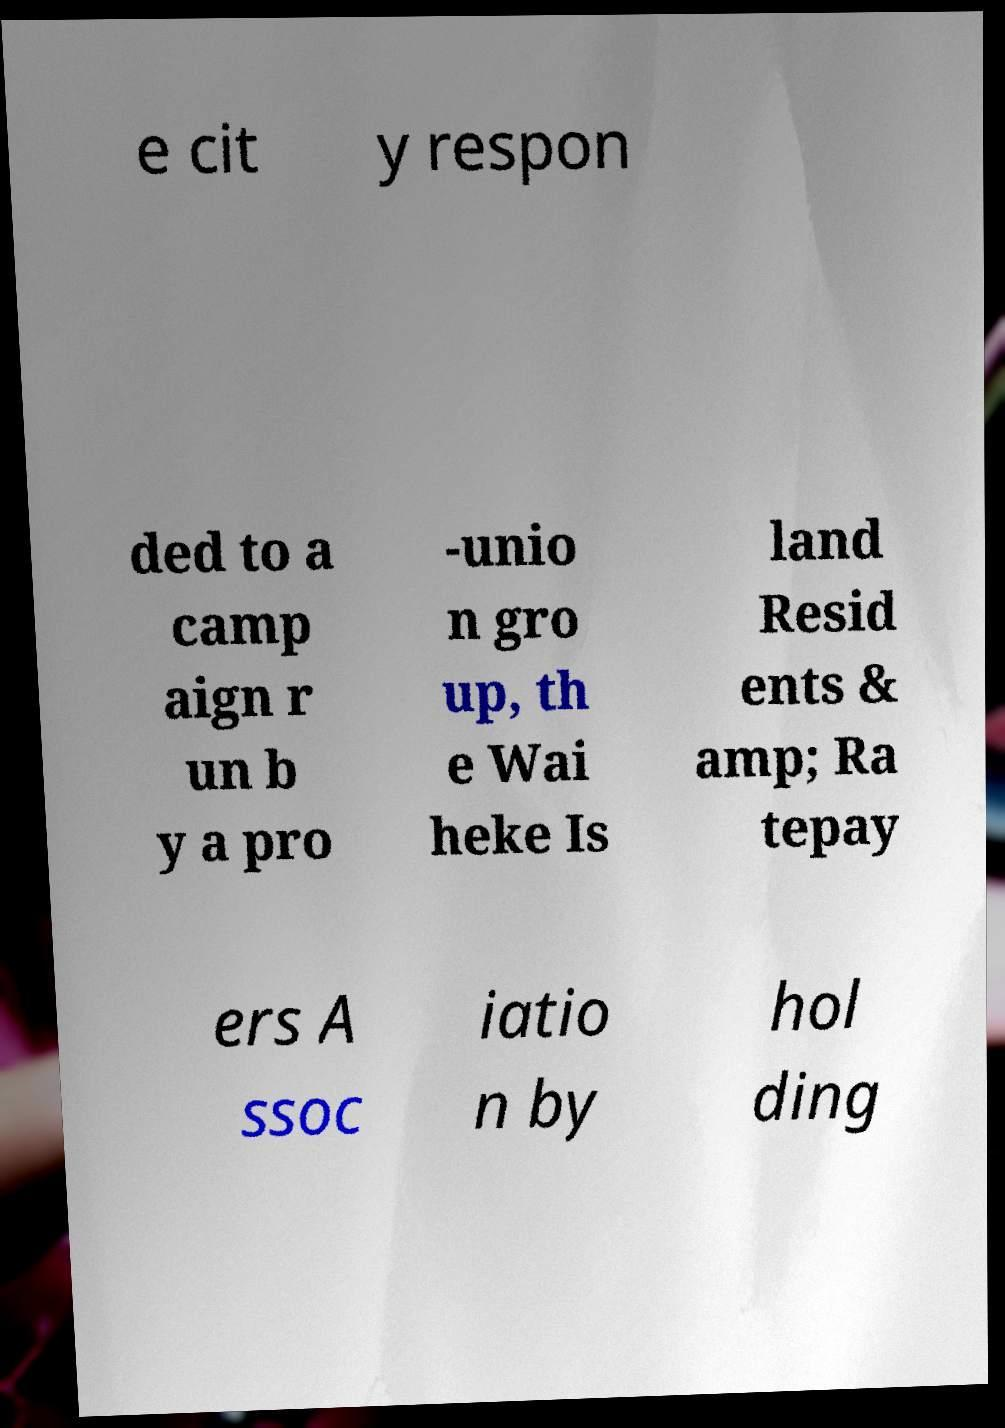Could you assist in decoding the text presented in this image and type it out clearly? e cit y respon ded to a camp aign r un b y a pro -unio n gro up, th e Wai heke Is land Resid ents & amp; Ra tepay ers A ssoc iatio n by hol ding 